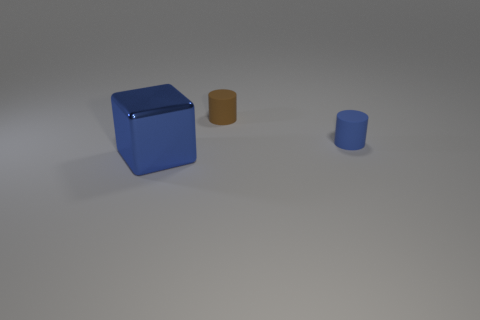Is there anything else that is made of the same material as the big blue block?
Keep it short and to the point. No. What material is the blue object that is behind the large metal block?
Provide a succinct answer. Rubber. What number of other things are there of the same shape as the blue metallic thing?
Your answer should be compact. 0. Does the big blue thing have the same shape as the small blue rubber object?
Your answer should be compact. No. There is a big blue thing; are there any brown objects in front of it?
Offer a terse response. No. What number of objects are green balls or big blue metallic cubes?
Give a very brief answer. 1. What number of other things are there of the same size as the brown rubber cylinder?
Give a very brief answer. 1. How many objects are on the right side of the cube and in front of the small brown matte cylinder?
Keep it short and to the point. 1. Does the blue object that is behind the big blue metallic cube have the same size as the matte thing left of the small blue thing?
Keep it short and to the point. Yes. There is a blue object that is behind the block; how big is it?
Make the answer very short. Small. 